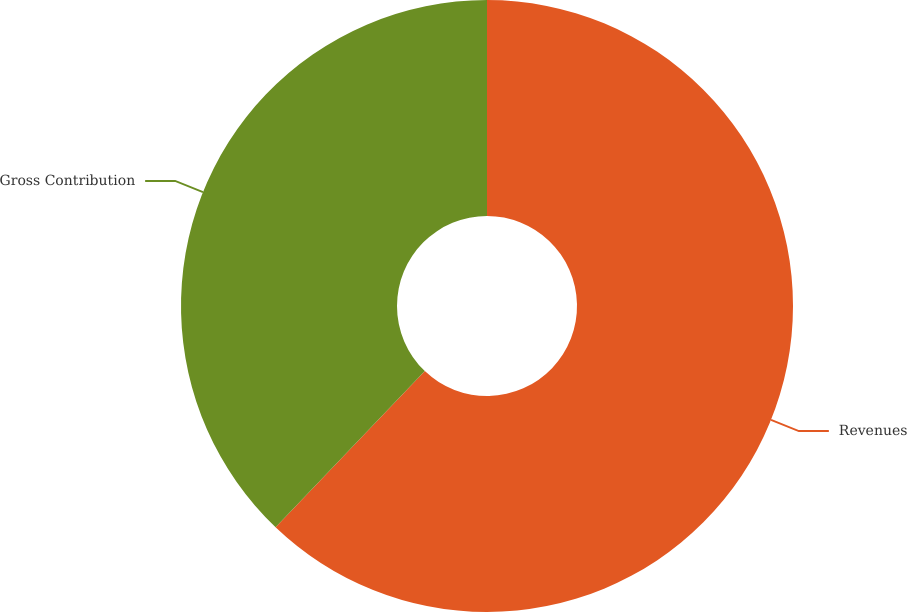Convert chart. <chart><loc_0><loc_0><loc_500><loc_500><pie_chart><fcel>Revenues<fcel>Gross Contribution<nl><fcel>62.14%<fcel>37.86%<nl></chart> 